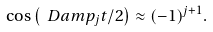Convert formula to latex. <formula><loc_0><loc_0><loc_500><loc_500>\cos \left ( \ D a m p _ { j } t / 2 \right ) \approx ( - 1 ) ^ { j + 1 } .</formula> 